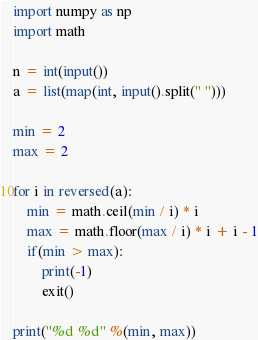Convert code to text. <code><loc_0><loc_0><loc_500><loc_500><_Python_>import numpy as np
import math

n = int(input())
a = list(map(int, input().split(" ")))

min = 2
max = 2

for i in reversed(a):
    min = math.ceil(min / i) * i
    max = math.floor(max / i) * i + i - 1
    if(min > max):
        print(-1)
        exit()

print("%d %d" %(min, max))</code> 